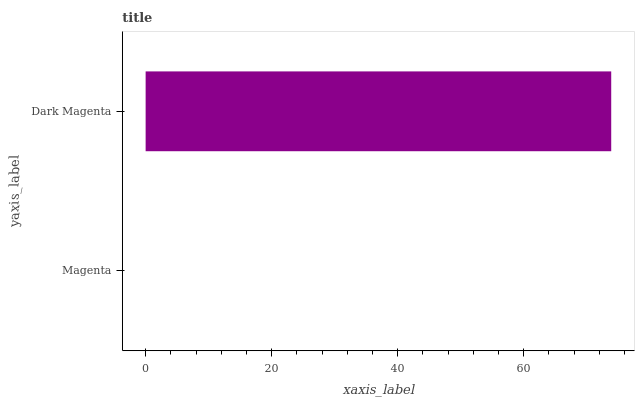Is Magenta the minimum?
Answer yes or no. Yes. Is Dark Magenta the maximum?
Answer yes or no. Yes. Is Dark Magenta the minimum?
Answer yes or no. No. Is Dark Magenta greater than Magenta?
Answer yes or no. Yes. Is Magenta less than Dark Magenta?
Answer yes or no. Yes. Is Magenta greater than Dark Magenta?
Answer yes or no. No. Is Dark Magenta less than Magenta?
Answer yes or no. No. Is Dark Magenta the high median?
Answer yes or no. Yes. Is Magenta the low median?
Answer yes or no. Yes. Is Magenta the high median?
Answer yes or no. No. Is Dark Magenta the low median?
Answer yes or no. No. 